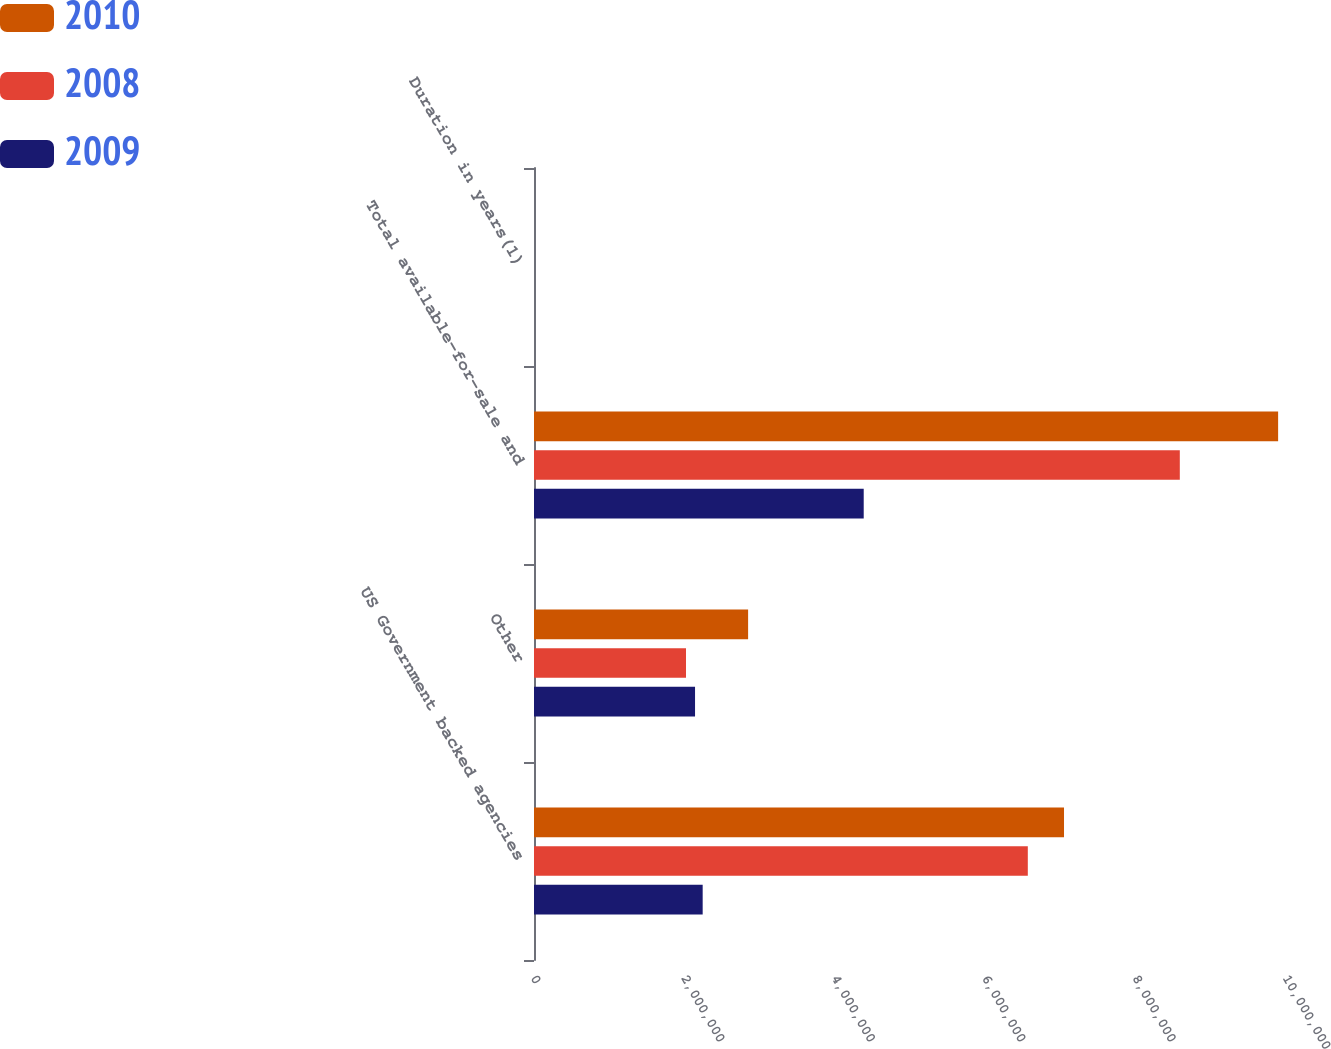<chart> <loc_0><loc_0><loc_500><loc_500><stacked_bar_chart><ecel><fcel>US Government backed agencies<fcel>Other<fcel>Total available-for-sale and<fcel>Duration in years(1)<nl><fcel>2010<fcel>7.04803e+06<fcel>2.84722e+06<fcel>9.89524e+06<fcel>3<nl><fcel>2008<fcel>6.56665e+06<fcel>2.02126e+06<fcel>8.58791e+06<fcel>2.4<nl><fcel>2009<fcel>2.24298e+06<fcel>2.14148e+06<fcel>4.38446e+06<fcel>5.2<nl></chart> 